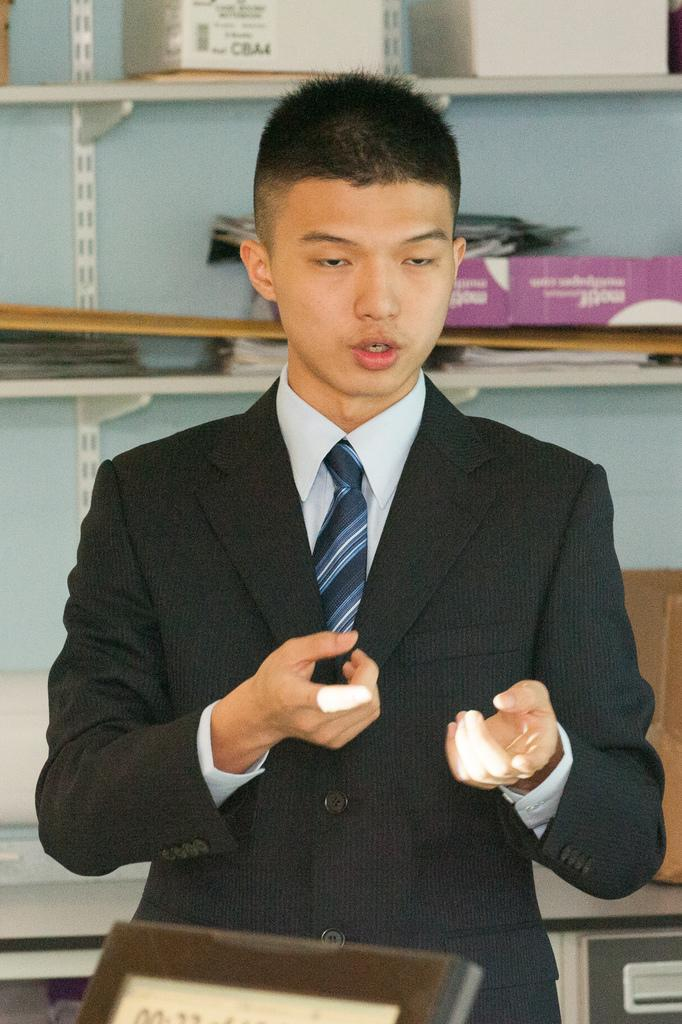Who is the main subject in the image? There is a boy in the image. What is the boy wearing? The boy is wearing a blazer, tie, and shirt. What piece of furniture can be seen in the image? There is a desk in the image. What type of storage is present in the image? There are shelves with objects in the image. What advice does the book on the shelf give to the boy in the image? There is no book present in the image, so it cannot provide any advice to the boy. 